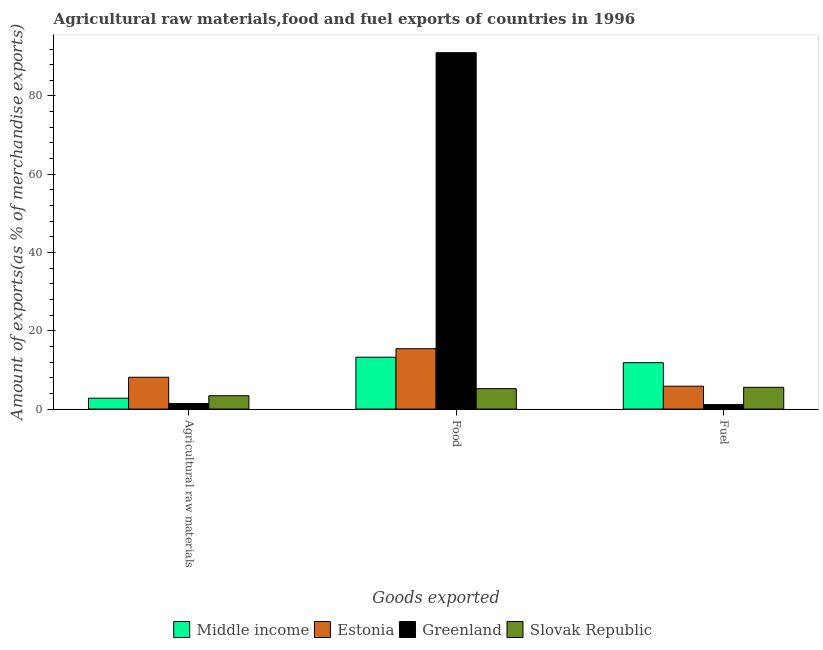How many groups of bars are there?
Give a very brief answer. 3. How many bars are there on the 1st tick from the right?
Your answer should be compact. 4. What is the label of the 2nd group of bars from the left?
Make the answer very short. Food. What is the percentage of raw materials exports in Greenland?
Offer a very short reply. 1.41. Across all countries, what is the maximum percentage of food exports?
Your response must be concise. 91.06. Across all countries, what is the minimum percentage of fuel exports?
Provide a short and direct response. 1.15. In which country was the percentage of raw materials exports maximum?
Offer a terse response. Estonia. In which country was the percentage of fuel exports minimum?
Your response must be concise. Greenland. What is the total percentage of fuel exports in the graph?
Your response must be concise. 24.41. What is the difference between the percentage of fuel exports in Estonia and that in Slovak Republic?
Ensure brevity in your answer.  0.28. What is the difference between the percentage of fuel exports in Estonia and the percentage of raw materials exports in Greenland?
Make the answer very short. 4.43. What is the average percentage of raw materials exports per country?
Offer a terse response. 3.94. What is the difference between the percentage of fuel exports and percentage of food exports in Middle income?
Provide a succinct answer. -1.4. What is the ratio of the percentage of food exports in Greenland to that in Estonia?
Ensure brevity in your answer.  5.9. Is the difference between the percentage of food exports in Greenland and Middle income greater than the difference between the percentage of fuel exports in Greenland and Middle income?
Give a very brief answer. Yes. What is the difference between the highest and the second highest percentage of food exports?
Your response must be concise. 75.63. What is the difference between the highest and the lowest percentage of food exports?
Give a very brief answer. 85.84. What does the 2nd bar from the left in Food represents?
Your answer should be compact. Estonia. What does the 2nd bar from the right in Agricultural raw materials represents?
Offer a terse response. Greenland. Is it the case that in every country, the sum of the percentage of raw materials exports and percentage of food exports is greater than the percentage of fuel exports?
Offer a very short reply. Yes. How many bars are there?
Give a very brief answer. 12. Are all the bars in the graph horizontal?
Your response must be concise. No. Are the values on the major ticks of Y-axis written in scientific E-notation?
Your answer should be compact. No. How are the legend labels stacked?
Offer a terse response. Horizontal. What is the title of the graph?
Offer a very short reply. Agricultural raw materials,food and fuel exports of countries in 1996. Does "Slovenia" appear as one of the legend labels in the graph?
Offer a terse response. No. What is the label or title of the X-axis?
Provide a short and direct response. Goods exported. What is the label or title of the Y-axis?
Offer a terse response. Amount of exports(as % of merchandise exports). What is the Amount of exports(as % of merchandise exports) of Middle income in Agricultural raw materials?
Your response must be concise. 2.78. What is the Amount of exports(as % of merchandise exports) in Estonia in Agricultural raw materials?
Your answer should be compact. 8.13. What is the Amount of exports(as % of merchandise exports) of Greenland in Agricultural raw materials?
Make the answer very short. 1.41. What is the Amount of exports(as % of merchandise exports) in Slovak Republic in Agricultural raw materials?
Provide a succinct answer. 3.42. What is the Amount of exports(as % of merchandise exports) of Middle income in Food?
Make the answer very short. 13.26. What is the Amount of exports(as % of merchandise exports) of Estonia in Food?
Keep it short and to the point. 15.43. What is the Amount of exports(as % of merchandise exports) of Greenland in Food?
Provide a succinct answer. 91.06. What is the Amount of exports(as % of merchandise exports) in Slovak Republic in Food?
Your answer should be very brief. 5.22. What is the Amount of exports(as % of merchandise exports) of Middle income in Fuel?
Provide a short and direct response. 11.85. What is the Amount of exports(as % of merchandise exports) of Estonia in Fuel?
Provide a succinct answer. 5.85. What is the Amount of exports(as % of merchandise exports) in Greenland in Fuel?
Give a very brief answer. 1.15. What is the Amount of exports(as % of merchandise exports) in Slovak Republic in Fuel?
Your answer should be very brief. 5.56. Across all Goods exported, what is the maximum Amount of exports(as % of merchandise exports) in Middle income?
Provide a succinct answer. 13.26. Across all Goods exported, what is the maximum Amount of exports(as % of merchandise exports) in Estonia?
Give a very brief answer. 15.43. Across all Goods exported, what is the maximum Amount of exports(as % of merchandise exports) of Greenland?
Your answer should be compact. 91.06. Across all Goods exported, what is the maximum Amount of exports(as % of merchandise exports) in Slovak Republic?
Your answer should be compact. 5.56. Across all Goods exported, what is the minimum Amount of exports(as % of merchandise exports) in Middle income?
Give a very brief answer. 2.78. Across all Goods exported, what is the minimum Amount of exports(as % of merchandise exports) of Estonia?
Your response must be concise. 5.85. Across all Goods exported, what is the minimum Amount of exports(as % of merchandise exports) of Greenland?
Offer a terse response. 1.15. Across all Goods exported, what is the minimum Amount of exports(as % of merchandise exports) in Slovak Republic?
Offer a terse response. 3.42. What is the total Amount of exports(as % of merchandise exports) in Middle income in the graph?
Provide a succinct answer. 27.89. What is the total Amount of exports(as % of merchandise exports) of Estonia in the graph?
Offer a very short reply. 29.4. What is the total Amount of exports(as % of merchandise exports) of Greenland in the graph?
Make the answer very short. 93.62. What is the total Amount of exports(as % of merchandise exports) of Slovak Republic in the graph?
Offer a terse response. 14.2. What is the difference between the Amount of exports(as % of merchandise exports) of Middle income in Agricultural raw materials and that in Food?
Make the answer very short. -10.47. What is the difference between the Amount of exports(as % of merchandise exports) of Estonia in Agricultural raw materials and that in Food?
Ensure brevity in your answer.  -7.3. What is the difference between the Amount of exports(as % of merchandise exports) of Greenland in Agricultural raw materials and that in Food?
Provide a succinct answer. -89.64. What is the difference between the Amount of exports(as % of merchandise exports) of Slovak Republic in Agricultural raw materials and that in Food?
Provide a short and direct response. -1.8. What is the difference between the Amount of exports(as % of merchandise exports) of Middle income in Agricultural raw materials and that in Fuel?
Provide a succinct answer. -9.07. What is the difference between the Amount of exports(as % of merchandise exports) in Estonia in Agricultural raw materials and that in Fuel?
Ensure brevity in your answer.  2.28. What is the difference between the Amount of exports(as % of merchandise exports) in Greenland in Agricultural raw materials and that in Fuel?
Provide a short and direct response. 0.27. What is the difference between the Amount of exports(as % of merchandise exports) in Slovak Republic in Agricultural raw materials and that in Fuel?
Offer a terse response. -2.15. What is the difference between the Amount of exports(as % of merchandise exports) in Middle income in Food and that in Fuel?
Provide a short and direct response. 1.4. What is the difference between the Amount of exports(as % of merchandise exports) of Estonia in Food and that in Fuel?
Give a very brief answer. 9.58. What is the difference between the Amount of exports(as % of merchandise exports) of Greenland in Food and that in Fuel?
Your response must be concise. 89.91. What is the difference between the Amount of exports(as % of merchandise exports) in Slovak Republic in Food and that in Fuel?
Your answer should be very brief. -0.35. What is the difference between the Amount of exports(as % of merchandise exports) of Middle income in Agricultural raw materials and the Amount of exports(as % of merchandise exports) of Estonia in Food?
Provide a succinct answer. -12.64. What is the difference between the Amount of exports(as % of merchandise exports) of Middle income in Agricultural raw materials and the Amount of exports(as % of merchandise exports) of Greenland in Food?
Provide a short and direct response. -88.27. What is the difference between the Amount of exports(as % of merchandise exports) of Middle income in Agricultural raw materials and the Amount of exports(as % of merchandise exports) of Slovak Republic in Food?
Offer a very short reply. -2.43. What is the difference between the Amount of exports(as % of merchandise exports) of Estonia in Agricultural raw materials and the Amount of exports(as % of merchandise exports) of Greenland in Food?
Keep it short and to the point. -82.93. What is the difference between the Amount of exports(as % of merchandise exports) of Estonia in Agricultural raw materials and the Amount of exports(as % of merchandise exports) of Slovak Republic in Food?
Make the answer very short. 2.91. What is the difference between the Amount of exports(as % of merchandise exports) in Greenland in Agricultural raw materials and the Amount of exports(as % of merchandise exports) in Slovak Republic in Food?
Your answer should be very brief. -3.8. What is the difference between the Amount of exports(as % of merchandise exports) of Middle income in Agricultural raw materials and the Amount of exports(as % of merchandise exports) of Estonia in Fuel?
Ensure brevity in your answer.  -3.06. What is the difference between the Amount of exports(as % of merchandise exports) of Middle income in Agricultural raw materials and the Amount of exports(as % of merchandise exports) of Greenland in Fuel?
Provide a succinct answer. 1.63. What is the difference between the Amount of exports(as % of merchandise exports) of Middle income in Agricultural raw materials and the Amount of exports(as % of merchandise exports) of Slovak Republic in Fuel?
Offer a very short reply. -2.78. What is the difference between the Amount of exports(as % of merchandise exports) in Estonia in Agricultural raw materials and the Amount of exports(as % of merchandise exports) in Greenland in Fuel?
Give a very brief answer. 6.98. What is the difference between the Amount of exports(as % of merchandise exports) in Estonia in Agricultural raw materials and the Amount of exports(as % of merchandise exports) in Slovak Republic in Fuel?
Provide a short and direct response. 2.57. What is the difference between the Amount of exports(as % of merchandise exports) in Greenland in Agricultural raw materials and the Amount of exports(as % of merchandise exports) in Slovak Republic in Fuel?
Keep it short and to the point. -4.15. What is the difference between the Amount of exports(as % of merchandise exports) in Middle income in Food and the Amount of exports(as % of merchandise exports) in Estonia in Fuel?
Offer a very short reply. 7.41. What is the difference between the Amount of exports(as % of merchandise exports) of Middle income in Food and the Amount of exports(as % of merchandise exports) of Greenland in Fuel?
Provide a succinct answer. 12.11. What is the difference between the Amount of exports(as % of merchandise exports) of Middle income in Food and the Amount of exports(as % of merchandise exports) of Slovak Republic in Fuel?
Offer a terse response. 7.69. What is the difference between the Amount of exports(as % of merchandise exports) of Estonia in Food and the Amount of exports(as % of merchandise exports) of Greenland in Fuel?
Your answer should be compact. 14.28. What is the difference between the Amount of exports(as % of merchandise exports) in Estonia in Food and the Amount of exports(as % of merchandise exports) in Slovak Republic in Fuel?
Ensure brevity in your answer.  9.86. What is the difference between the Amount of exports(as % of merchandise exports) in Greenland in Food and the Amount of exports(as % of merchandise exports) in Slovak Republic in Fuel?
Make the answer very short. 85.49. What is the average Amount of exports(as % of merchandise exports) of Middle income per Goods exported?
Your response must be concise. 9.3. What is the average Amount of exports(as % of merchandise exports) of Estonia per Goods exported?
Offer a terse response. 9.8. What is the average Amount of exports(as % of merchandise exports) of Greenland per Goods exported?
Provide a succinct answer. 31.21. What is the average Amount of exports(as % of merchandise exports) of Slovak Republic per Goods exported?
Make the answer very short. 4.73. What is the difference between the Amount of exports(as % of merchandise exports) of Middle income and Amount of exports(as % of merchandise exports) of Estonia in Agricultural raw materials?
Offer a very short reply. -5.34. What is the difference between the Amount of exports(as % of merchandise exports) in Middle income and Amount of exports(as % of merchandise exports) in Greenland in Agricultural raw materials?
Make the answer very short. 1.37. What is the difference between the Amount of exports(as % of merchandise exports) in Middle income and Amount of exports(as % of merchandise exports) in Slovak Republic in Agricultural raw materials?
Your response must be concise. -0.63. What is the difference between the Amount of exports(as % of merchandise exports) of Estonia and Amount of exports(as % of merchandise exports) of Greenland in Agricultural raw materials?
Provide a succinct answer. 6.71. What is the difference between the Amount of exports(as % of merchandise exports) in Estonia and Amount of exports(as % of merchandise exports) in Slovak Republic in Agricultural raw materials?
Ensure brevity in your answer.  4.71. What is the difference between the Amount of exports(as % of merchandise exports) of Greenland and Amount of exports(as % of merchandise exports) of Slovak Republic in Agricultural raw materials?
Give a very brief answer. -2. What is the difference between the Amount of exports(as % of merchandise exports) in Middle income and Amount of exports(as % of merchandise exports) in Estonia in Food?
Give a very brief answer. -2.17. What is the difference between the Amount of exports(as % of merchandise exports) of Middle income and Amount of exports(as % of merchandise exports) of Greenland in Food?
Keep it short and to the point. -77.8. What is the difference between the Amount of exports(as % of merchandise exports) of Middle income and Amount of exports(as % of merchandise exports) of Slovak Republic in Food?
Provide a short and direct response. 8.04. What is the difference between the Amount of exports(as % of merchandise exports) of Estonia and Amount of exports(as % of merchandise exports) of Greenland in Food?
Your answer should be very brief. -75.63. What is the difference between the Amount of exports(as % of merchandise exports) in Estonia and Amount of exports(as % of merchandise exports) in Slovak Republic in Food?
Provide a succinct answer. 10.21. What is the difference between the Amount of exports(as % of merchandise exports) of Greenland and Amount of exports(as % of merchandise exports) of Slovak Republic in Food?
Make the answer very short. 85.84. What is the difference between the Amount of exports(as % of merchandise exports) in Middle income and Amount of exports(as % of merchandise exports) in Estonia in Fuel?
Your response must be concise. 6. What is the difference between the Amount of exports(as % of merchandise exports) of Middle income and Amount of exports(as % of merchandise exports) of Greenland in Fuel?
Provide a succinct answer. 10.7. What is the difference between the Amount of exports(as % of merchandise exports) of Middle income and Amount of exports(as % of merchandise exports) of Slovak Republic in Fuel?
Your response must be concise. 6.29. What is the difference between the Amount of exports(as % of merchandise exports) of Estonia and Amount of exports(as % of merchandise exports) of Greenland in Fuel?
Your answer should be very brief. 4.7. What is the difference between the Amount of exports(as % of merchandise exports) of Estonia and Amount of exports(as % of merchandise exports) of Slovak Republic in Fuel?
Your answer should be very brief. 0.28. What is the difference between the Amount of exports(as % of merchandise exports) of Greenland and Amount of exports(as % of merchandise exports) of Slovak Republic in Fuel?
Your answer should be very brief. -4.41. What is the ratio of the Amount of exports(as % of merchandise exports) of Middle income in Agricultural raw materials to that in Food?
Your response must be concise. 0.21. What is the ratio of the Amount of exports(as % of merchandise exports) of Estonia in Agricultural raw materials to that in Food?
Your answer should be very brief. 0.53. What is the ratio of the Amount of exports(as % of merchandise exports) of Greenland in Agricultural raw materials to that in Food?
Keep it short and to the point. 0.02. What is the ratio of the Amount of exports(as % of merchandise exports) in Slovak Republic in Agricultural raw materials to that in Food?
Your answer should be very brief. 0.66. What is the ratio of the Amount of exports(as % of merchandise exports) in Middle income in Agricultural raw materials to that in Fuel?
Your answer should be compact. 0.23. What is the ratio of the Amount of exports(as % of merchandise exports) in Estonia in Agricultural raw materials to that in Fuel?
Provide a succinct answer. 1.39. What is the ratio of the Amount of exports(as % of merchandise exports) in Greenland in Agricultural raw materials to that in Fuel?
Your answer should be compact. 1.23. What is the ratio of the Amount of exports(as % of merchandise exports) of Slovak Republic in Agricultural raw materials to that in Fuel?
Offer a very short reply. 0.61. What is the ratio of the Amount of exports(as % of merchandise exports) of Middle income in Food to that in Fuel?
Offer a terse response. 1.12. What is the ratio of the Amount of exports(as % of merchandise exports) in Estonia in Food to that in Fuel?
Ensure brevity in your answer.  2.64. What is the ratio of the Amount of exports(as % of merchandise exports) of Greenland in Food to that in Fuel?
Your answer should be very brief. 79.23. What is the ratio of the Amount of exports(as % of merchandise exports) of Slovak Republic in Food to that in Fuel?
Your answer should be compact. 0.94. What is the difference between the highest and the second highest Amount of exports(as % of merchandise exports) in Middle income?
Keep it short and to the point. 1.4. What is the difference between the highest and the second highest Amount of exports(as % of merchandise exports) of Estonia?
Give a very brief answer. 7.3. What is the difference between the highest and the second highest Amount of exports(as % of merchandise exports) in Greenland?
Offer a terse response. 89.64. What is the difference between the highest and the second highest Amount of exports(as % of merchandise exports) in Slovak Republic?
Offer a terse response. 0.35. What is the difference between the highest and the lowest Amount of exports(as % of merchandise exports) in Middle income?
Your answer should be very brief. 10.47. What is the difference between the highest and the lowest Amount of exports(as % of merchandise exports) of Estonia?
Your answer should be compact. 9.58. What is the difference between the highest and the lowest Amount of exports(as % of merchandise exports) of Greenland?
Offer a very short reply. 89.91. What is the difference between the highest and the lowest Amount of exports(as % of merchandise exports) of Slovak Republic?
Your answer should be compact. 2.15. 